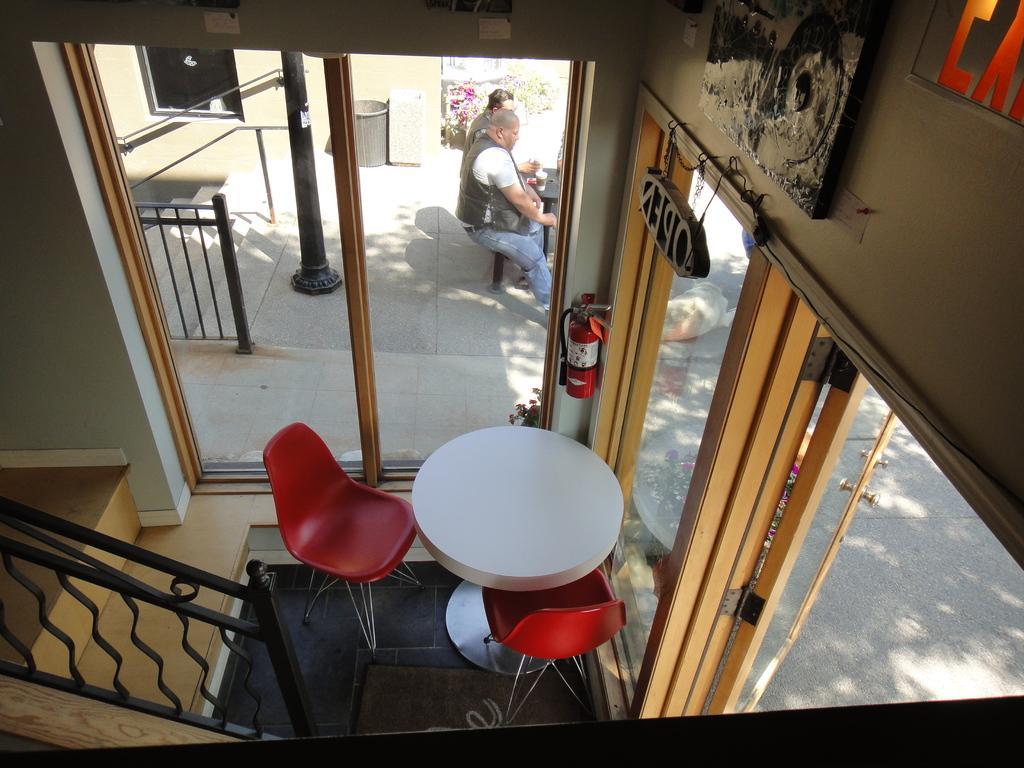How would you summarize this image in a sentence or two? In this Picture we can top view of the house in which down we can see the table and two red color chair, and beautiful iron grill railing and step, In front there a two person sitting and having cup of coffee and a green lawn with flowers and dustbin. 